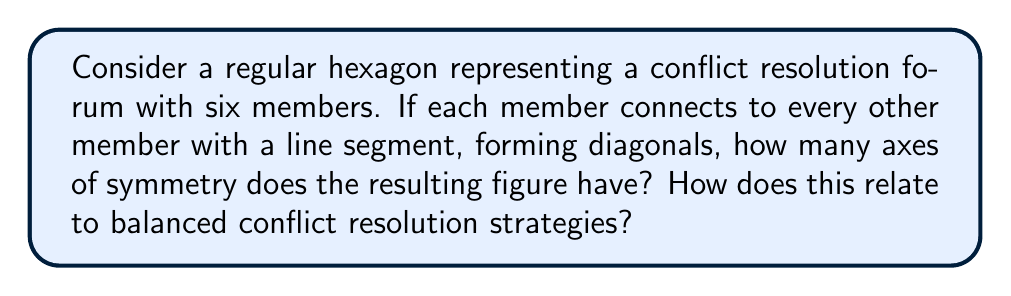Can you answer this question? Let's approach this step-by-step:

1) First, let's visualize the figure:

[asy]
unitsize(2cm);
pair[] vertices = {dir(0), dir(60), dir(120), dir(180), dir(240), dir(300)};
for(int i = 0; i < 6; ++i)
  for(int j = i+1; j < 6; ++j)
    draw(vertices[i]--vertices[j]);
draw(circle(origin, 1), dashed);
for(int i = 0; i < 6; ++i)
  draw(origin--vertices[i], dashed);
[/asy]

2) A regular hexagon itself has 12 axes of symmetry:
   - 6 axes passing through opposite vertices
   - 6 axes passing through the midpoints of opposite sides

3) When we add the diagonals, we need to check if these axes still preserve symmetry.

4) The diagonals form a complete graph $K_6$ inside the hexagon. This means every vertex is connected to every other vertex.

5) Due to this complete connectivity, all axes of symmetry of the original hexagon are preserved in the new figure.

6) Therefore, the figure with diagonals also has 12 axes of symmetry.

7) In terms of conflict resolution:
   - The 6 axes through vertices represent direct one-on-one resolutions between opposing members.
   - The 6 axes through sides represent mediated resolutions involving pairs of adjacent members.
   - The complete connectivity ensures all members have equal input, promoting balanced strategies.
   - The high degree of symmetry (12 axes) illustrates multiple balanced approaches to resolution.
Answer: 12 axes of symmetry 